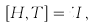Convert formula to latex. <formula><loc_0><loc_0><loc_500><loc_500>\left [ H , T \right ] = i I \, ,</formula> 